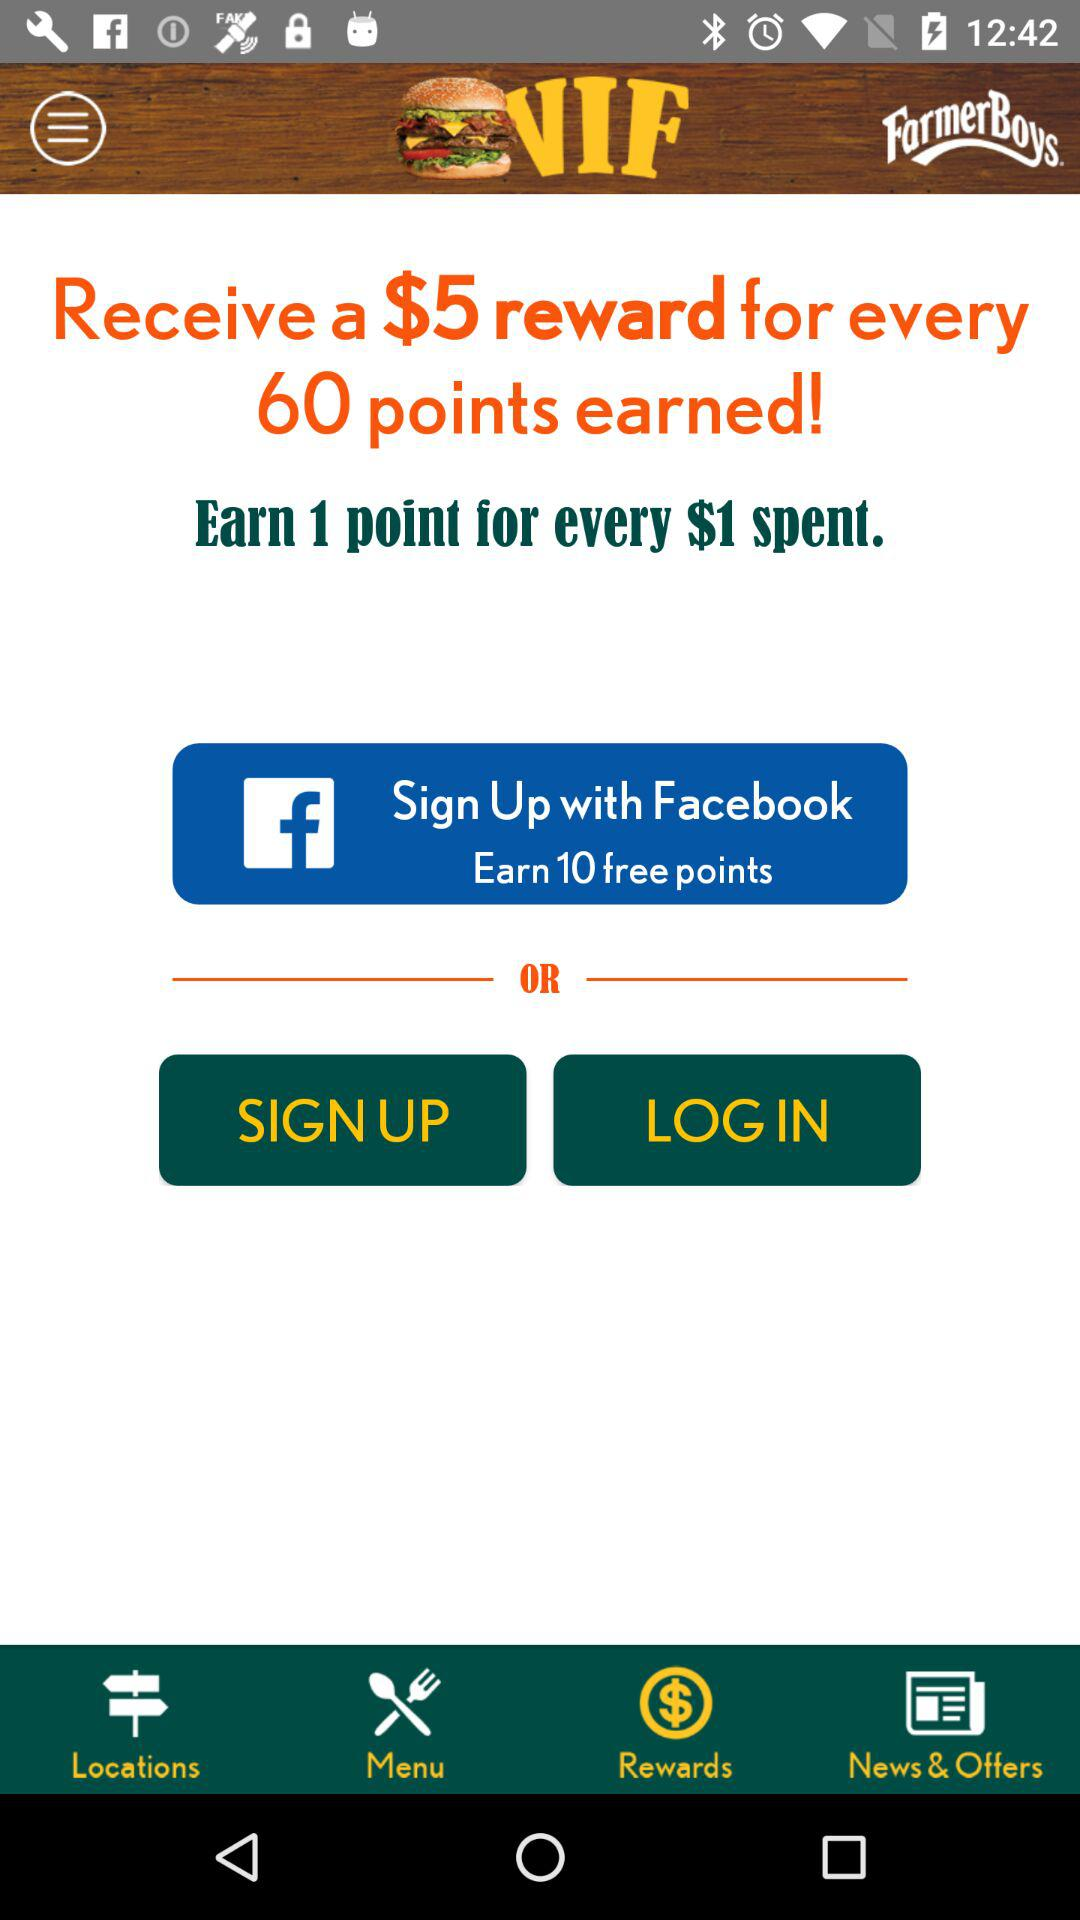What is the selected tab? The selected tab is "Rewards". 